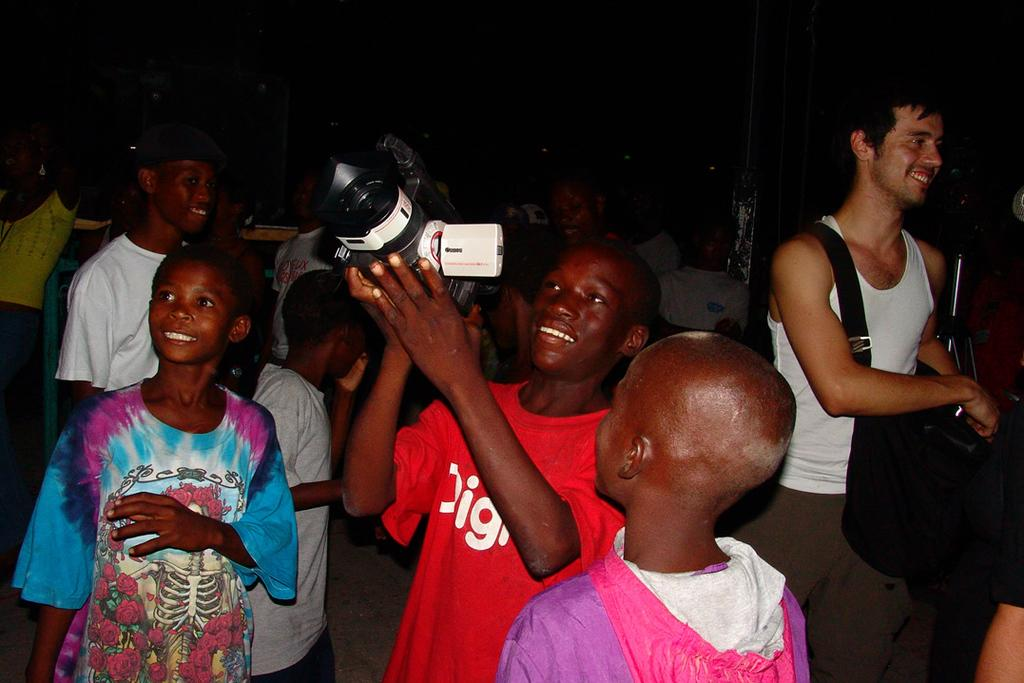What is the man in the image holding? The man is holding a camera in the image. Who else is present in the image? There are two other men standing beside him. What can be seen in the background of the image? There is a group of people in the background of the image. How are the people in the background positioned? The people in the background are standing and smiling. How many feet are visible in the image? There is no specific mention of feet in the image, so it is not possible to determine how many are visible. 